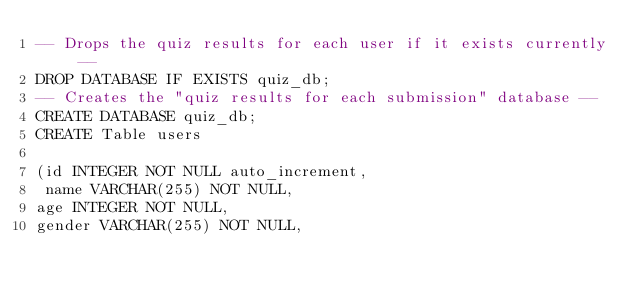Convert code to text. <code><loc_0><loc_0><loc_500><loc_500><_SQL_>-- Drops the quiz results for each user if it exists currently --
DROP DATABASE IF EXISTS quiz_db;
-- Creates the "quiz results for each submission" database --
CREATE DATABASE quiz_db;
CREATE Table users

(id INTEGER NOT NULL auto_increment,
 name VARCHAR(255) NOT NULL,
age INTEGER NOT NULL,
gender VARCHAR(255) NOT NULL,</code> 